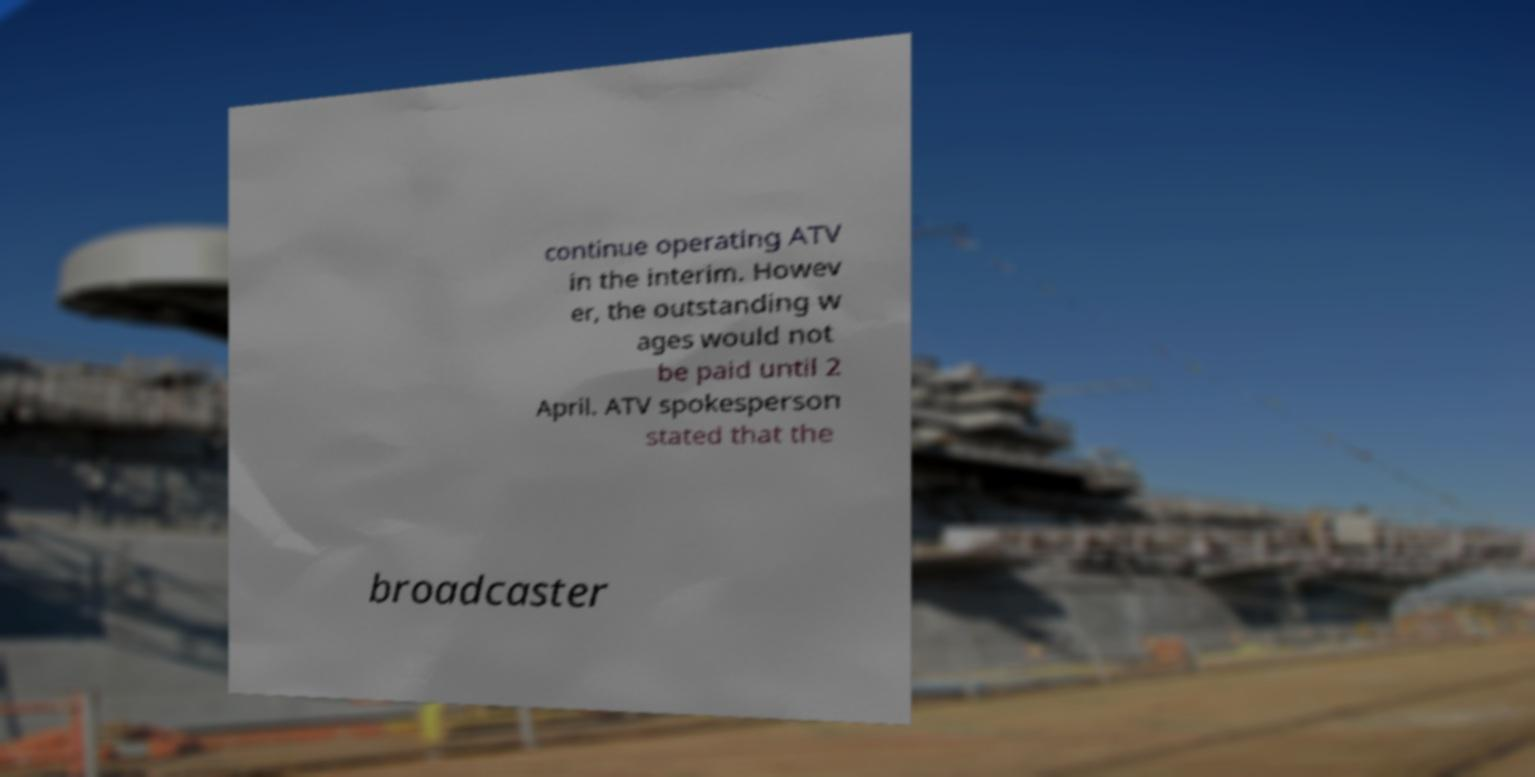There's text embedded in this image that I need extracted. Can you transcribe it verbatim? continue operating ATV in the interim. Howev er, the outstanding w ages would not be paid until 2 April. ATV spokesperson stated that the broadcaster 